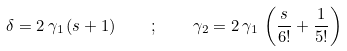<formula> <loc_0><loc_0><loc_500><loc_500>\delta = 2 \, \gamma _ { 1 } \, ( s + 1 ) \quad ; \quad \gamma _ { 2 } = 2 \, \gamma _ { 1 } \, \left ( \frac { s } { 6 ! } + \frac { 1 } { 5 ! } \right )</formula> 